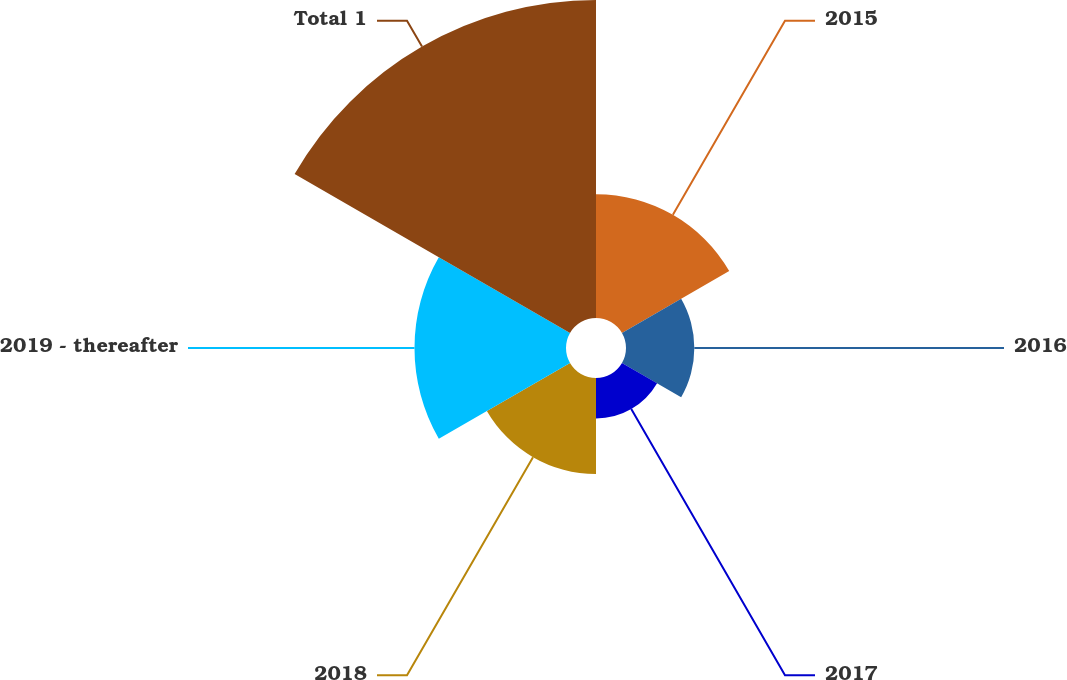Convert chart. <chart><loc_0><loc_0><loc_500><loc_500><pie_chart><fcel>2015<fcel>2016<fcel>2017<fcel>2018<fcel>2019 - thereafter<fcel>Total 1<nl><fcel>15.51%<fcel>8.56%<fcel>5.08%<fcel>12.03%<fcel>18.98%<fcel>39.84%<nl></chart> 